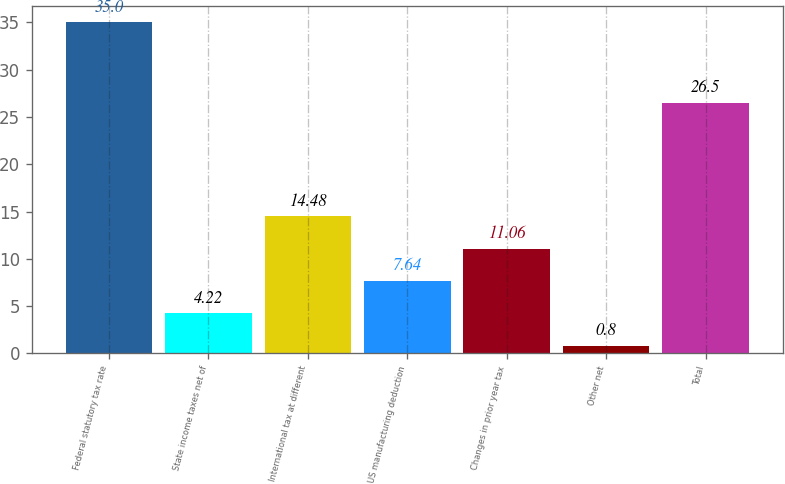Convert chart to OTSL. <chart><loc_0><loc_0><loc_500><loc_500><bar_chart><fcel>Federal statutory tax rate<fcel>State income taxes net of<fcel>International tax at different<fcel>US manufacturing deduction<fcel>Changes in prior year tax<fcel>Other net<fcel>Total<nl><fcel>35<fcel>4.22<fcel>14.48<fcel>7.64<fcel>11.06<fcel>0.8<fcel>26.5<nl></chart> 